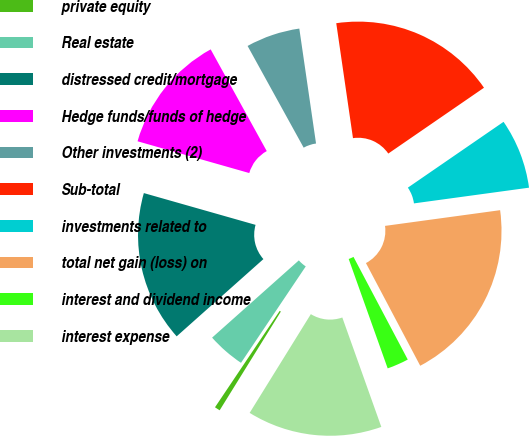<chart> <loc_0><loc_0><loc_500><loc_500><pie_chart><fcel>private equity<fcel>Real estate<fcel>distressed credit/mortgage<fcel>Hedge funds/funds of hedge<fcel>Other investments (2)<fcel>Sub-total<fcel>investments related to<fcel>total net gain (loss) on<fcel>interest and dividend income<fcel>interest expense<nl><fcel>0.58%<fcel>4.01%<fcel>15.99%<fcel>12.57%<fcel>5.72%<fcel>17.71%<fcel>7.43%<fcel>19.42%<fcel>2.29%<fcel>14.28%<nl></chart> 